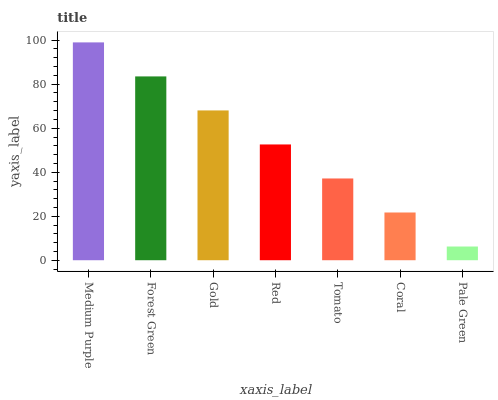Is Pale Green the minimum?
Answer yes or no. Yes. Is Medium Purple the maximum?
Answer yes or no. Yes. Is Forest Green the minimum?
Answer yes or no. No. Is Forest Green the maximum?
Answer yes or no. No. Is Medium Purple greater than Forest Green?
Answer yes or no. Yes. Is Forest Green less than Medium Purple?
Answer yes or no. Yes. Is Forest Green greater than Medium Purple?
Answer yes or no. No. Is Medium Purple less than Forest Green?
Answer yes or no. No. Is Red the high median?
Answer yes or no. Yes. Is Red the low median?
Answer yes or no. Yes. Is Gold the high median?
Answer yes or no. No. Is Tomato the low median?
Answer yes or no. No. 